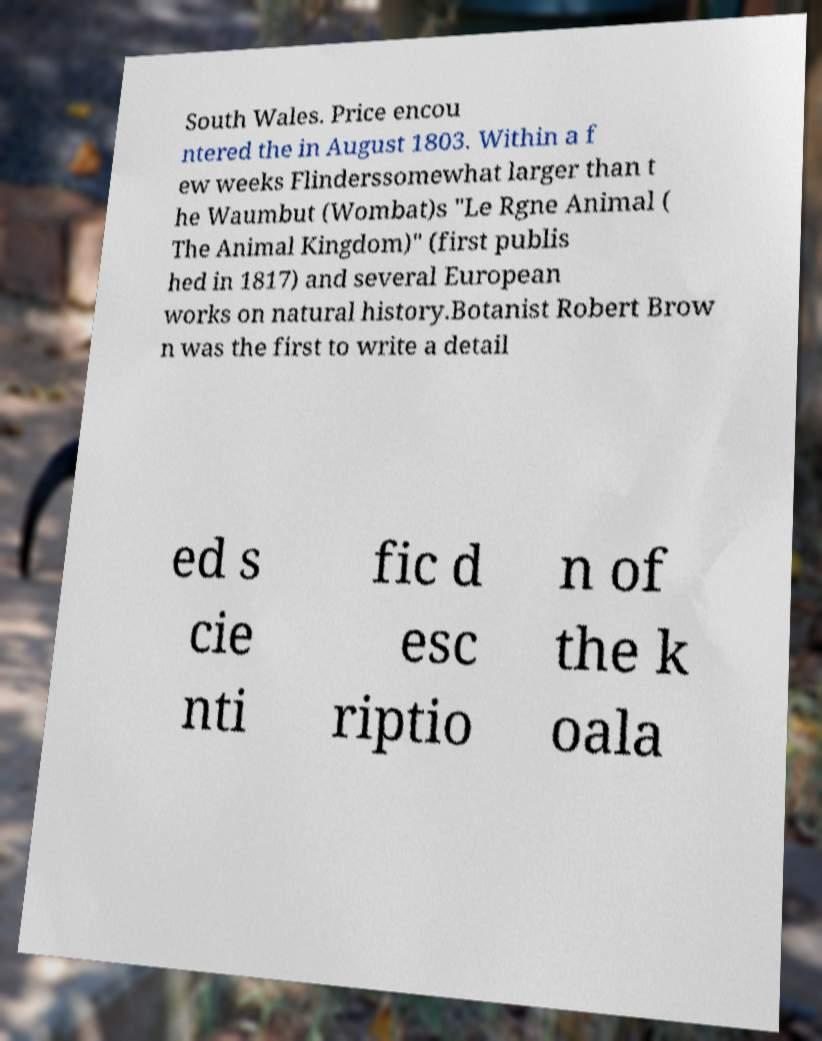Could you assist in decoding the text presented in this image and type it out clearly? South Wales. Price encou ntered the in August 1803. Within a f ew weeks Flinderssomewhat larger than t he Waumbut (Wombat)s "Le Rgne Animal ( The Animal Kingdom)" (first publis hed in 1817) and several European works on natural history.Botanist Robert Brow n was the first to write a detail ed s cie nti fic d esc riptio n of the k oala 